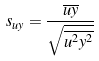<formula> <loc_0><loc_0><loc_500><loc_500>s _ { u y } = \frac { \overline { u y } } { \sqrt { \overline { u ^ { 2 } } \overline { y ^ { 2 } } } }</formula> 